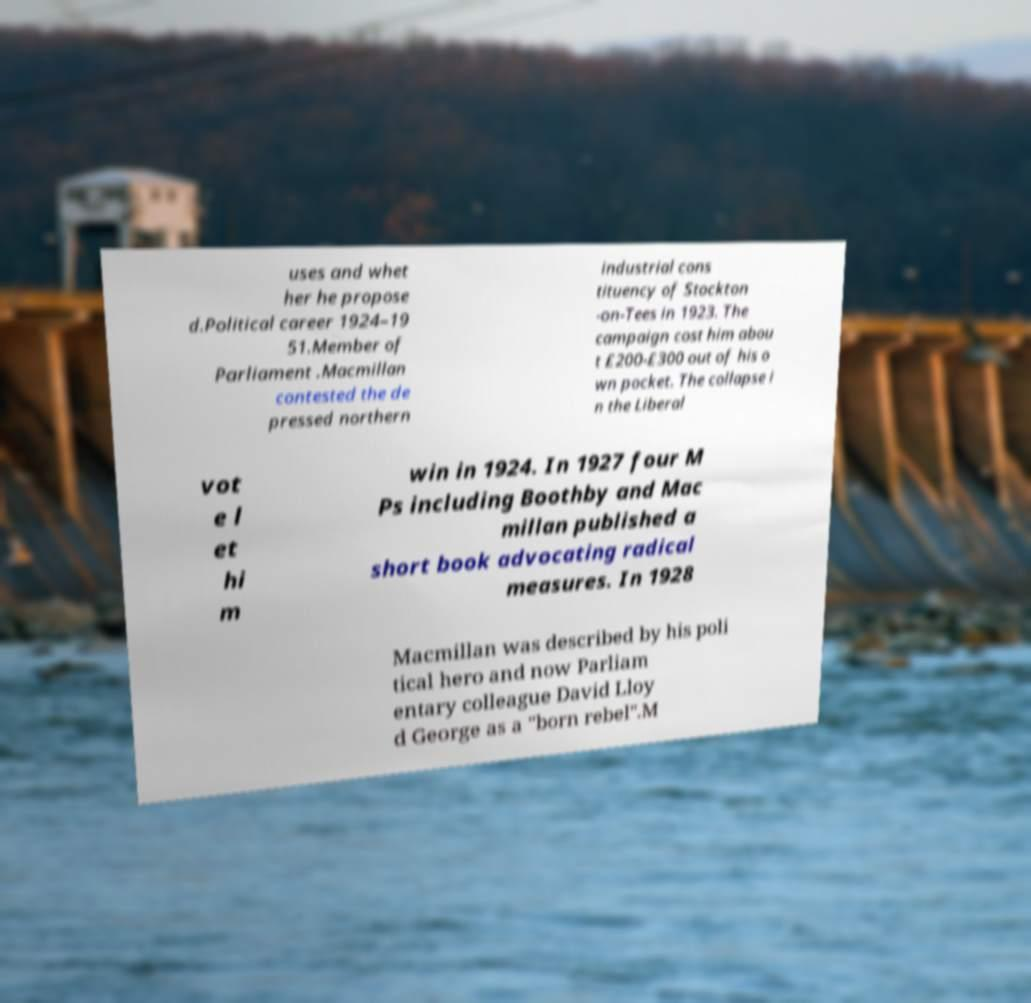Please identify and transcribe the text found in this image. uses and whet her he propose d.Political career 1924–19 51.Member of Parliament .Macmillan contested the de pressed northern industrial cons tituency of Stockton -on-Tees in 1923. The campaign cost him abou t £200-£300 out of his o wn pocket. The collapse i n the Liberal vot e l et hi m win in 1924. In 1927 four M Ps including Boothby and Mac millan published a short book advocating radical measures. In 1928 Macmillan was described by his poli tical hero and now Parliam entary colleague David Lloy d George as a "born rebel".M 